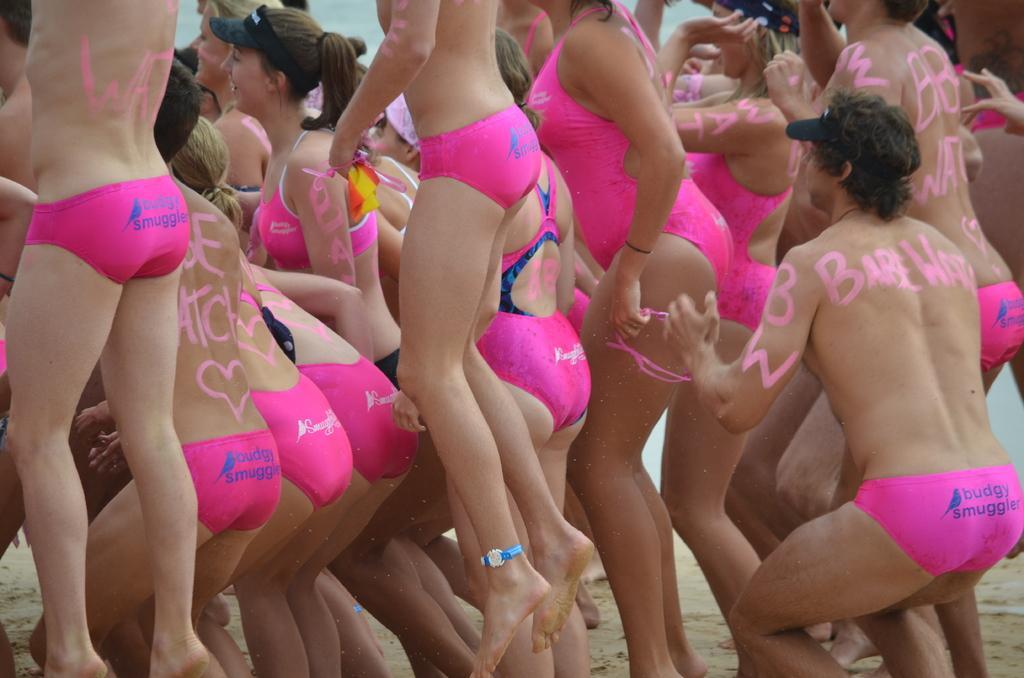In one or two sentences, can you explain what this image depicts? In this image I can see few persons wearing pink colored dresses are standing. I can see something is written on their bodies with pink color. I can see the sand and the water in the background. 